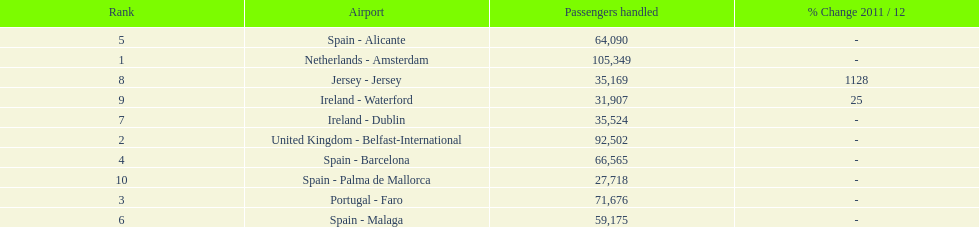Looking at the top 10 busiest routes to and from london southend airport what is the average number of passengers handled? 58,967.5. 